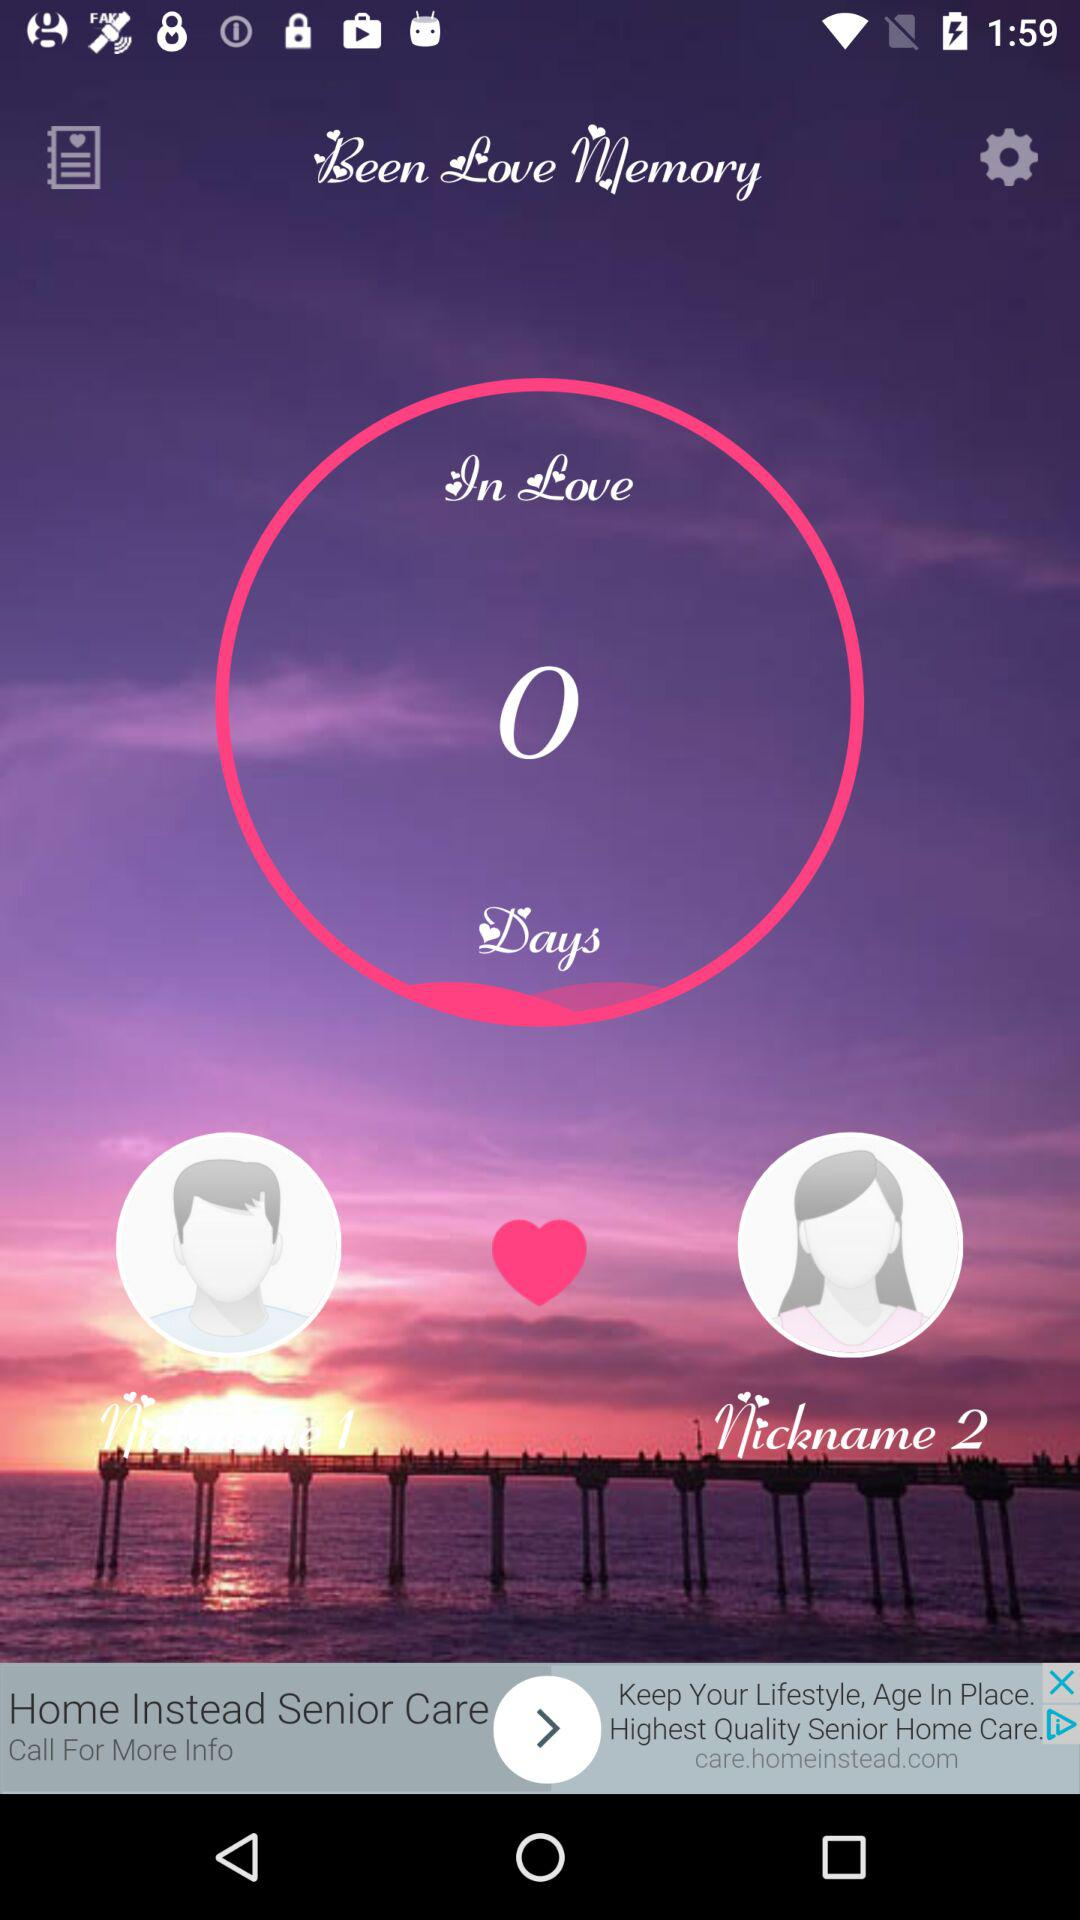How many total days are given? There are 0 days. 